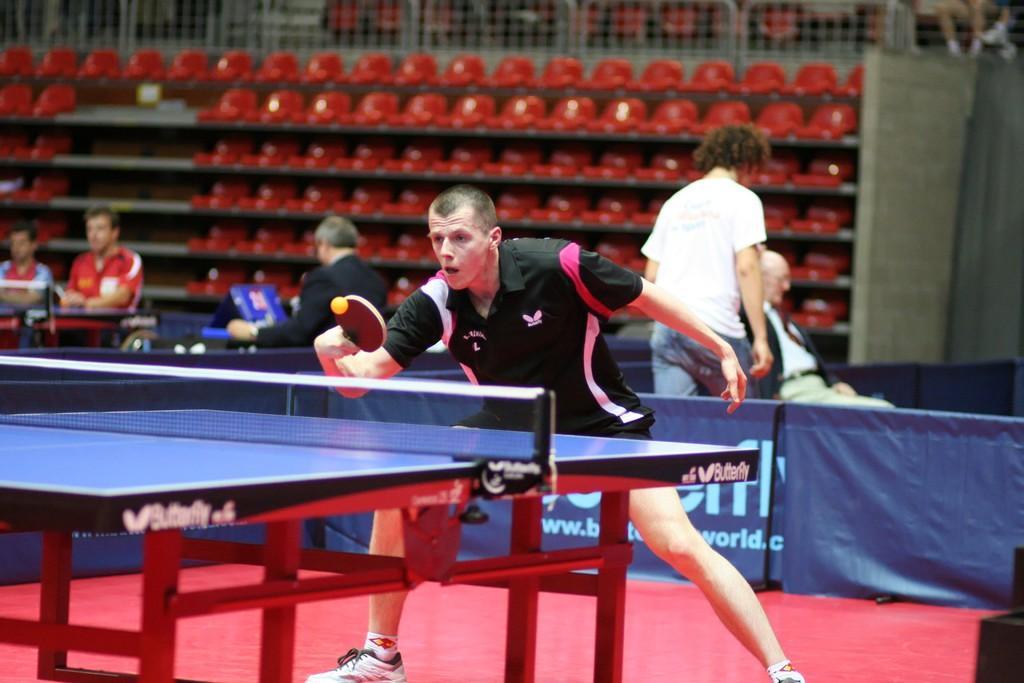Could you give a brief overview of what you see in this image? In this picture we can see few players playing a table tennis. Here we can see one man sitting. Here we can see one man walking. This is a red carpet. This is a blue flexi. 